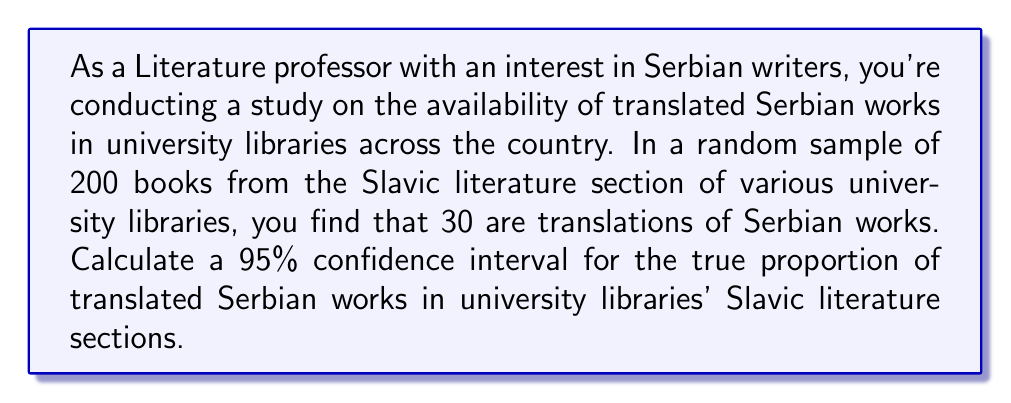Solve this math problem. Let's approach this step-by-step:

1) We're dealing with a proportion, so we'll use the formula for a confidence interval for a proportion:

   $$\hat{p} \pm z^* \sqrt{\frac{\hat{p}(1-\hat{p})}{n}}$$

   Where:
   $\hat{p}$ is the sample proportion
   $z^*$ is the critical value for the desired confidence level
   $n$ is the sample size

2) Calculate $\hat{p}$:
   $\hat{p} = \frac{30}{200} = 0.15$

3) For a 95% confidence interval, $z^* = 1.96$

4) Now, let's plug these values into our formula:

   $$0.15 \pm 1.96 \sqrt{\frac{0.15(1-0.15)}{200}}$$

5) Simplify under the square root:
   $$0.15 \pm 1.96 \sqrt{\frac{0.1275}{200}} = 0.15 \pm 1.96 \sqrt{0.0006375}$$

6) Calculate:
   $$0.15 \pm 1.96 (0.0252) = 0.15 \pm 0.04944$$

7) Therefore, the confidence interval is:
   $$(0.15 - 0.04944, 0.15 + 0.04944) = (0.10056, 0.19944)$$

8) Rounding to three decimal places:
   $$(0.101, 0.199)$$
Answer: (0.101, 0.199) 